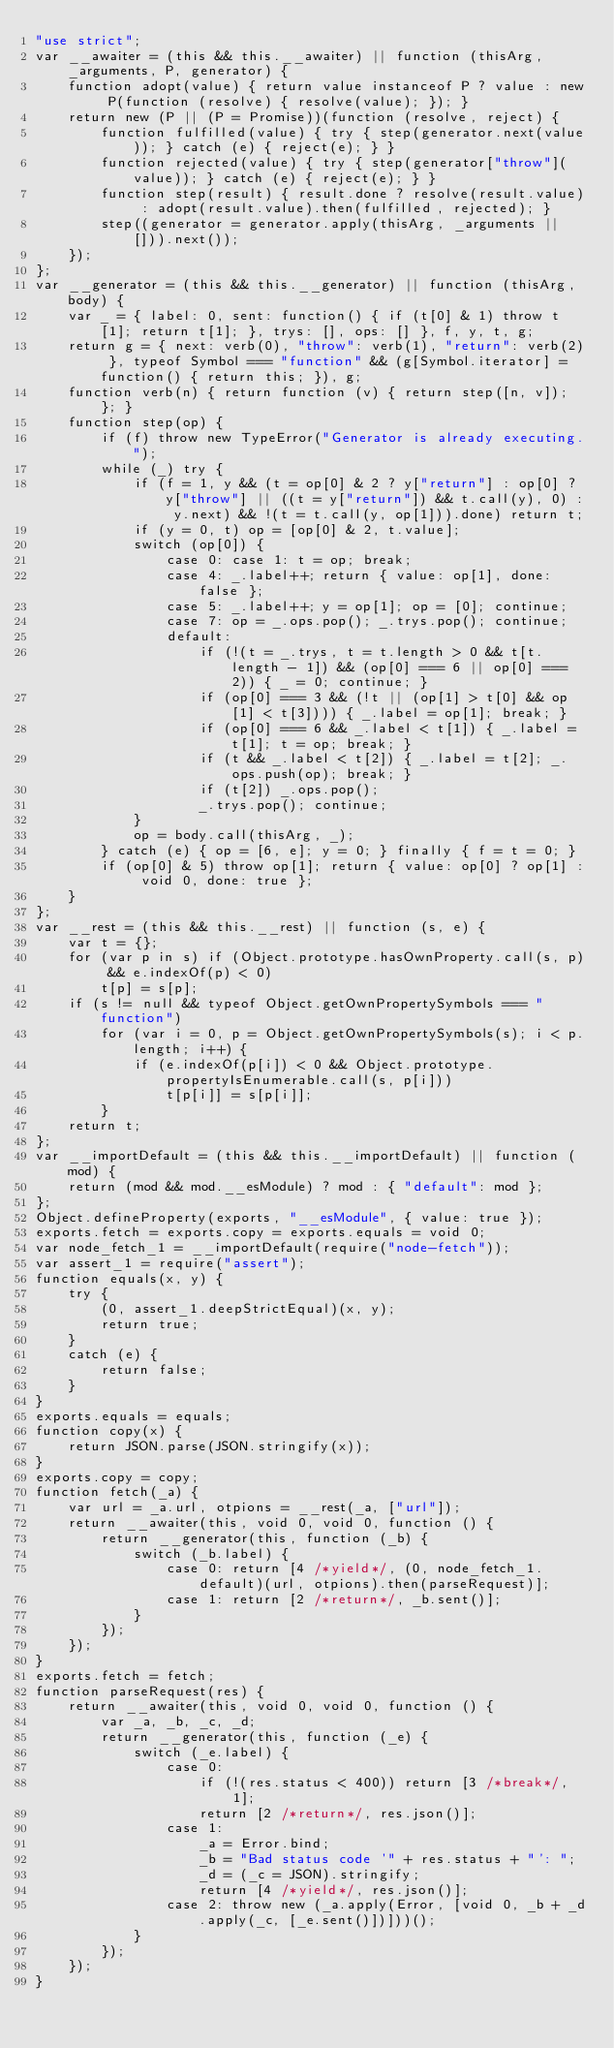Convert code to text. <code><loc_0><loc_0><loc_500><loc_500><_JavaScript_>"use strict";
var __awaiter = (this && this.__awaiter) || function (thisArg, _arguments, P, generator) {
    function adopt(value) { return value instanceof P ? value : new P(function (resolve) { resolve(value); }); }
    return new (P || (P = Promise))(function (resolve, reject) {
        function fulfilled(value) { try { step(generator.next(value)); } catch (e) { reject(e); } }
        function rejected(value) { try { step(generator["throw"](value)); } catch (e) { reject(e); } }
        function step(result) { result.done ? resolve(result.value) : adopt(result.value).then(fulfilled, rejected); }
        step((generator = generator.apply(thisArg, _arguments || [])).next());
    });
};
var __generator = (this && this.__generator) || function (thisArg, body) {
    var _ = { label: 0, sent: function() { if (t[0] & 1) throw t[1]; return t[1]; }, trys: [], ops: [] }, f, y, t, g;
    return g = { next: verb(0), "throw": verb(1), "return": verb(2) }, typeof Symbol === "function" && (g[Symbol.iterator] = function() { return this; }), g;
    function verb(n) { return function (v) { return step([n, v]); }; }
    function step(op) {
        if (f) throw new TypeError("Generator is already executing.");
        while (_) try {
            if (f = 1, y && (t = op[0] & 2 ? y["return"] : op[0] ? y["throw"] || ((t = y["return"]) && t.call(y), 0) : y.next) && !(t = t.call(y, op[1])).done) return t;
            if (y = 0, t) op = [op[0] & 2, t.value];
            switch (op[0]) {
                case 0: case 1: t = op; break;
                case 4: _.label++; return { value: op[1], done: false };
                case 5: _.label++; y = op[1]; op = [0]; continue;
                case 7: op = _.ops.pop(); _.trys.pop(); continue;
                default:
                    if (!(t = _.trys, t = t.length > 0 && t[t.length - 1]) && (op[0] === 6 || op[0] === 2)) { _ = 0; continue; }
                    if (op[0] === 3 && (!t || (op[1] > t[0] && op[1] < t[3]))) { _.label = op[1]; break; }
                    if (op[0] === 6 && _.label < t[1]) { _.label = t[1]; t = op; break; }
                    if (t && _.label < t[2]) { _.label = t[2]; _.ops.push(op); break; }
                    if (t[2]) _.ops.pop();
                    _.trys.pop(); continue;
            }
            op = body.call(thisArg, _);
        } catch (e) { op = [6, e]; y = 0; } finally { f = t = 0; }
        if (op[0] & 5) throw op[1]; return { value: op[0] ? op[1] : void 0, done: true };
    }
};
var __rest = (this && this.__rest) || function (s, e) {
    var t = {};
    for (var p in s) if (Object.prototype.hasOwnProperty.call(s, p) && e.indexOf(p) < 0)
        t[p] = s[p];
    if (s != null && typeof Object.getOwnPropertySymbols === "function")
        for (var i = 0, p = Object.getOwnPropertySymbols(s); i < p.length; i++) {
            if (e.indexOf(p[i]) < 0 && Object.prototype.propertyIsEnumerable.call(s, p[i]))
                t[p[i]] = s[p[i]];
        }
    return t;
};
var __importDefault = (this && this.__importDefault) || function (mod) {
    return (mod && mod.__esModule) ? mod : { "default": mod };
};
Object.defineProperty(exports, "__esModule", { value: true });
exports.fetch = exports.copy = exports.equals = void 0;
var node_fetch_1 = __importDefault(require("node-fetch"));
var assert_1 = require("assert");
function equals(x, y) {
    try {
        (0, assert_1.deepStrictEqual)(x, y);
        return true;
    }
    catch (e) {
        return false;
    }
}
exports.equals = equals;
function copy(x) {
    return JSON.parse(JSON.stringify(x));
}
exports.copy = copy;
function fetch(_a) {
    var url = _a.url, otpions = __rest(_a, ["url"]);
    return __awaiter(this, void 0, void 0, function () {
        return __generator(this, function (_b) {
            switch (_b.label) {
                case 0: return [4 /*yield*/, (0, node_fetch_1.default)(url, otpions).then(parseRequest)];
                case 1: return [2 /*return*/, _b.sent()];
            }
        });
    });
}
exports.fetch = fetch;
function parseRequest(res) {
    return __awaiter(this, void 0, void 0, function () {
        var _a, _b, _c, _d;
        return __generator(this, function (_e) {
            switch (_e.label) {
                case 0:
                    if (!(res.status < 400)) return [3 /*break*/, 1];
                    return [2 /*return*/, res.json()];
                case 1:
                    _a = Error.bind;
                    _b = "Bad status code '" + res.status + "': ";
                    _d = (_c = JSON).stringify;
                    return [4 /*yield*/, res.json()];
                case 2: throw new (_a.apply(Error, [void 0, _b + _d.apply(_c, [_e.sent()])]))();
            }
        });
    });
}
</code> 